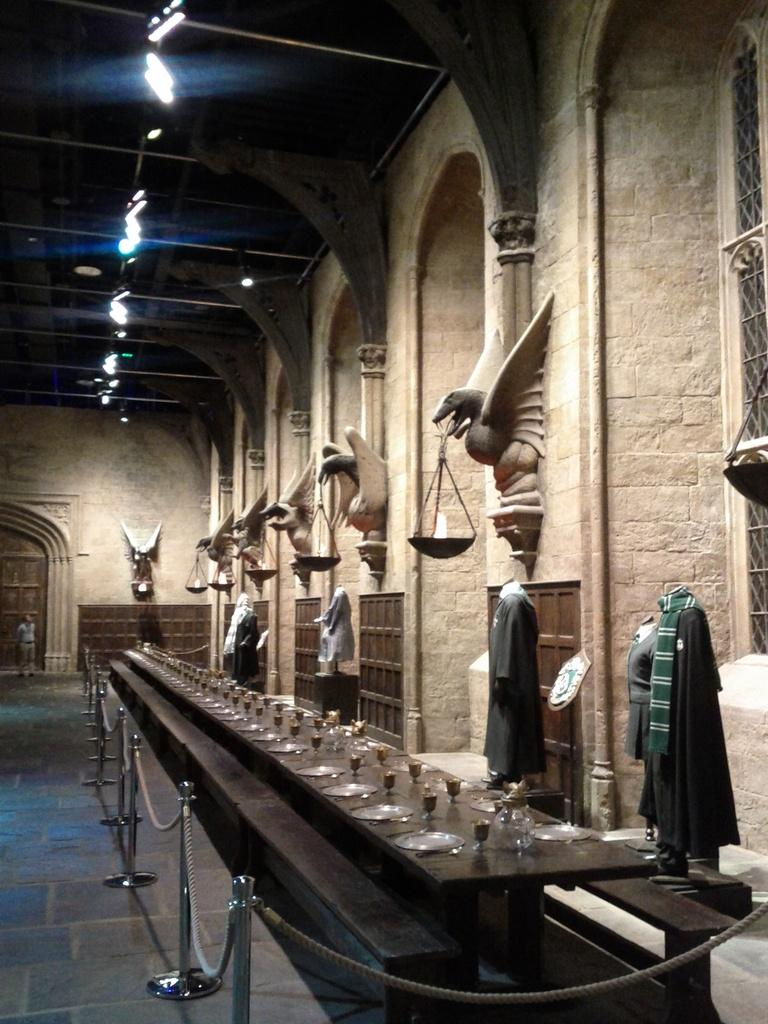What is located on the right side of the image? There is a fountain on the right side of the image. What can be seen on the wall in the image? There are sculptures on the wall in the image. How large is the dining table in the image? The dining table is very big in the image. What items are present on the dining table? There are wine glasses and plates on the dining table in the image. Reasoning: Let' Let's think step by step in order to produce the conversation. We start by identifying the main subjects and objects in the image based on the provided facts. We then formulate questions that focus on the location and characteristics of these subjects and objects, ensuring that each question can be answered definitively with the information given. We avoid yes/no questions and ensure that the language is simple and clear. Absurd Question/Answer: What type of work are the ants doing in the image? There are no ants present in the image. What class of people is depicted in the image? The image does not depict any specific class of people; it features a fountain, sculptures, and a dining table. How many ants are crawling on the sculptures in the image? There are no ants present in the image. What type of class is being taught in the image? The image does not depict any class or teaching activity; it features a fountain, sculptures, and a dining table. 